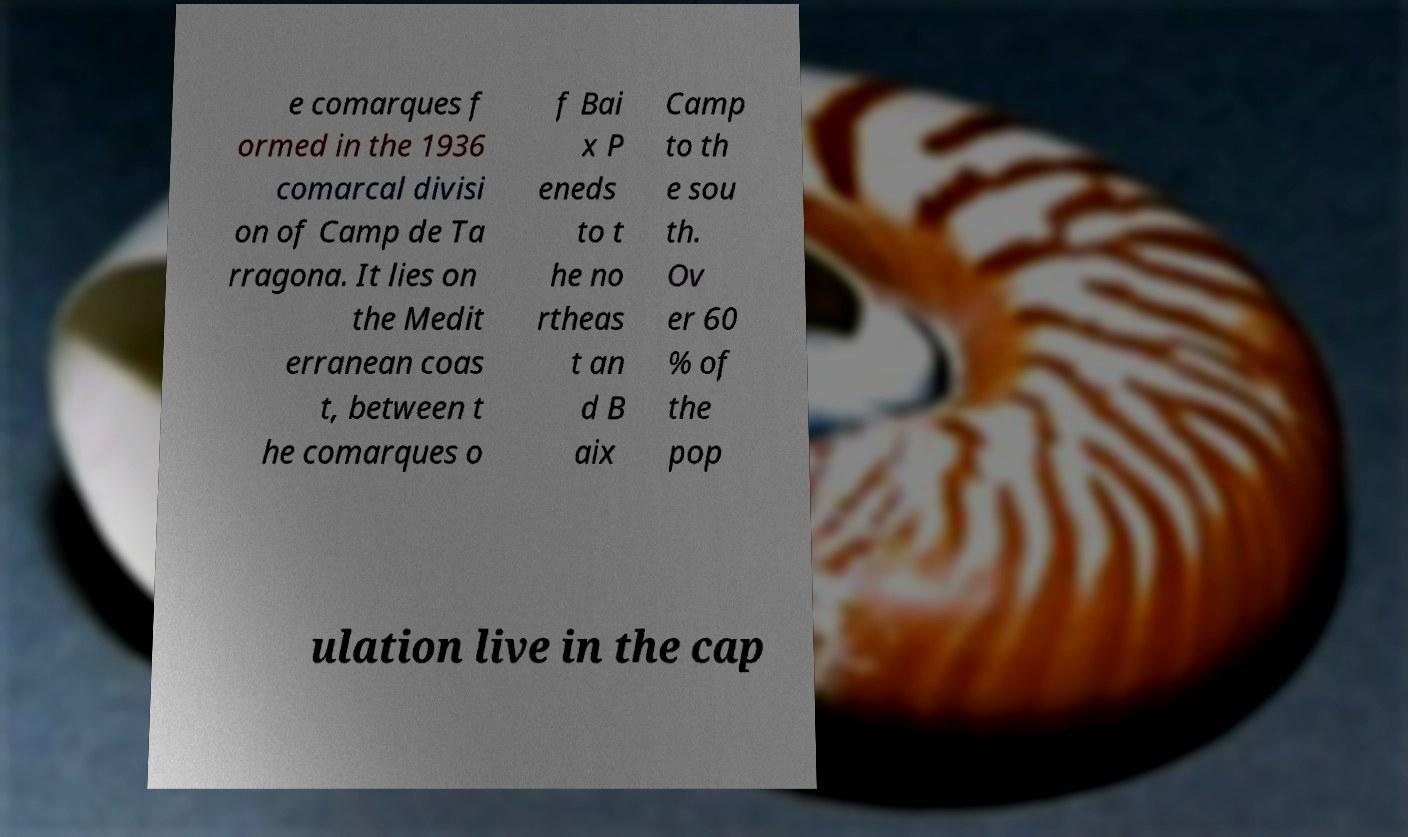Please identify and transcribe the text found in this image. e comarques f ormed in the 1936 comarcal divisi on of Camp de Ta rragona. It lies on the Medit erranean coas t, between t he comarques o f Bai x P eneds to t he no rtheas t an d B aix Camp to th e sou th. Ov er 60 % of the pop ulation live in the cap 